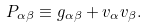<formula> <loc_0><loc_0><loc_500><loc_500>P _ { \alpha \beta } \equiv g _ { \alpha \beta } + v _ { \alpha } v _ { \beta } .</formula> 